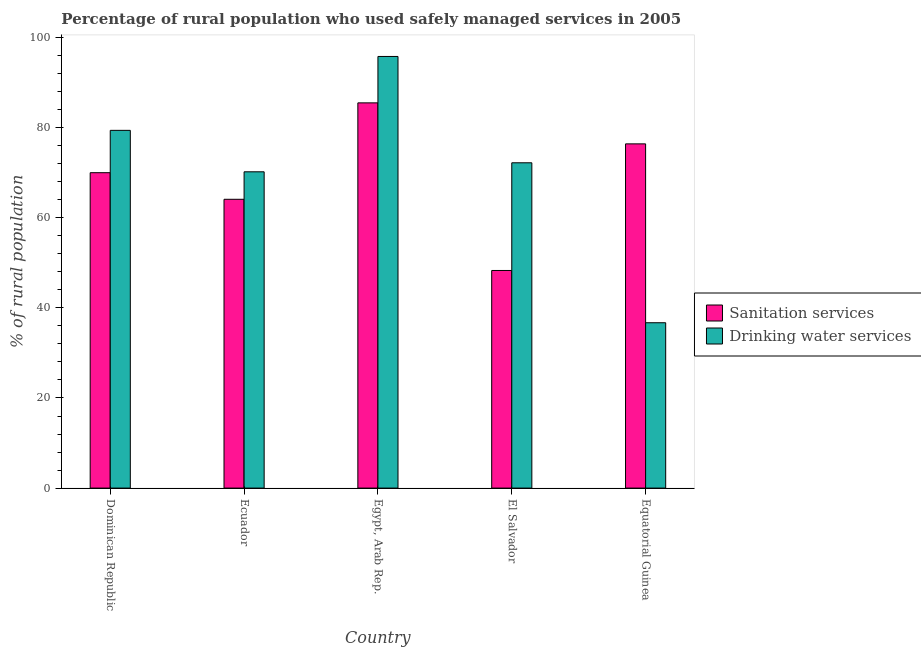How many bars are there on the 4th tick from the left?
Your response must be concise. 2. How many bars are there on the 2nd tick from the right?
Your answer should be compact. 2. What is the label of the 3rd group of bars from the left?
Your answer should be very brief. Egypt, Arab Rep. In how many cases, is the number of bars for a given country not equal to the number of legend labels?
Offer a very short reply. 0. What is the percentage of rural population who used sanitation services in Egypt, Arab Rep.?
Your response must be concise. 85.5. Across all countries, what is the maximum percentage of rural population who used drinking water services?
Provide a short and direct response. 95.8. Across all countries, what is the minimum percentage of rural population who used sanitation services?
Provide a succinct answer. 48.3. In which country was the percentage of rural population who used sanitation services maximum?
Give a very brief answer. Egypt, Arab Rep. In which country was the percentage of rural population who used sanitation services minimum?
Offer a very short reply. El Salvador. What is the total percentage of rural population who used sanitation services in the graph?
Your answer should be very brief. 344.3. What is the difference between the percentage of rural population who used drinking water services in Ecuador and that in Egypt, Arab Rep.?
Provide a short and direct response. -25.6. What is the difference between the percentage of rural population who used drinking water services in Ecuador and the percentage of rural population who used sanitation services in Egypt, Arab Rep.?
Your answer should be very brief. -15.3. What is the average percentage of rural population who used drinking water services per country?
Provide a short and direct response. 70.86. What is the difference between the percentage of rural population who used drinking water services and percentage of rural population who used sanitation services in Equatorial Guinea?
Provide a short and direct response. -39.7. In how many countries, is the percentage of rural population who used sanitation services greater than 80 %?
Give a very brief answer. 1. What is the ratio of the percentage of rural population who used drinking water services in Egypt, Arab Rep. to that in El Salvador?
Keep it short and to the point. 1.33. Is the percentage of rural population who used sanitation services in Dominican Republic less than that in El Salvador?
Give a very brief answer. No. What is the difference between the highest and the second highest percentage of rural population who used drinking water services?
Your response must be concise. 16.4. What is the difference between the highest and the lowest percentage of rural population who used sanitation services?
Your answer should be compact. 37.2. In how many countries, is the percentage of rural population who used drinking water services greater than the average percentage of rural population who used drinking water services taken over all countries?
Offer a terse response. 3. Is the sum of the percentage of rural population who used drinking water services in Dominican Republic and Ecuador greater than the maximum percentage of rural population who used sanitation services across all countries?
Your answer should be very brief. Yes. What does the 2nd bar from the left in Ecuador represents?
Your response must be concise. Drinking water services. What does the 1st bar from the right in Egypt, Arab Rep. represents?
Offer a very short reply. Drinking water services. Are all the bars in the graph horizontal?
Provide a short and direct response. No. How many countries are there in the graph?
Give a very brief answer. 5. What is the difference between two consecutive major ticks on the Y-axis?
Provide a succinct answer. 20. Are the values on the major ticks of Y-axis written in scientific E-notation?
Provide a short and direct response. No. Does the graph contain any zero values?
Provide a succinct answer. No. How many legend labels are there?
Offer a terse response. 2. What is the title of the graph?
Your answer should be compact. Percentage of rural population who used safely managed services in 2005. What is the label or title of the X-axis?
Your answer should be very brief. Country. What is the label or title of the Y-axis?
Offer a terse response. % of rural population. What is the % of rural population in Sanitation services in Dominican Republic?
Your answer should be compact. 70. What is the % of rural population of Drinking water services in Dominican Republic?
Offer a terse response. 79.4. What is the % of rural population of Sanitation services in Ecuador?
Your answer should be compact. 64.1. What is the % of rural population in Drinking water services in Ecuador?
Make the answer very short. 70.2. What is the % of rural population in Sanitation services in Egypt, Arab Rep.?
Ensure brevity in your answer.  85.5. What is the % of rural population of Drinking water services in Egypt, Arab Rep.?
Keep it short and to the point. 95.8. What is the % of rural population in Sanitation services in El Salvador?
Keep it short and to the point. 48.3. What is the % of rural population in Drinking water services in El Salvador?
Your response must be concise. 72.2. What is the % of rural population of Sanitation services in Equatorial Guinea?
Provide a short and direct response. 76.4. What is the % of rural population in Drinking water services in Equatorial Guinea?
Offer a terse response. 36.7. Across all countries, what is the maximum % of rural population of Sanitation services?
Give a very brief answer. 85.5. Across all countries, what is the maximum % of rural population in Drinking water services?
Offer a very short reply. 95.8. Across all countries, what is the minimum % of rural population of Sanitation services?
Give a very brief answer. 48.3. Across all countries, what is the minimum % of rural population in Drinking water services?
Make the answer very short. 36.7. What is the total % of rural population in Sanitation services in the graph?
Offer a terse response. 344.3. What is the total % of rural population in Drinking water services in the graph?
Your answer should be very brief. 354.3. What is the difference between the % of rural population of Drinking water services in Dominican Republic and that in Ecuador?
Keep it short and to the point. 9.2. What is the difference between the % of rural population of Sanitation services in Dominican Republic and that in Egypt, Arab Rep.?
Ensure brevity in your answer.  -15.5. What is the difference between the % of rural population of Drinking water services in Dominican Republic and that in Egypt, Arab Rep.?
Keep it short and to the point. -16.4. What is the difference between the % of rural population in Sanitation services in Dominican Republic and that in El Salvador?
Ensure brevity in your answer.  21.7. What is the difference between the % of rural population in Sanitation services in Dominican Republic and that in Equatorial Guinea?
Make the answer very short. -6.4. What is the difference between the % of rural population in Drinking water services in Dominican Republic and that in Equatorial Guinea?
Your response must be concise. 42.7. What is the difference between the % of rural population in Sanitation services in Ecuador and that in Egypt, Arab Rep.?
Provide a succinct answer. -21.4. What is the difference between the % of rural population of Drinking water services in Ecuador and that in Egypt, Arab Rep.?
Ensure brevity in your answer.  -25.6. What is the difference between the % of rural population of Drinking water services in Ecuador and that in El Salvador?
Your answer should be compact. -2. What is the difference between the % of rural population of Sanitation services in Ecuador and that in Equatorial Guinea?
Ensure brevity in your answer.  -12.3. What is the difference between the % of rural population of Drinking water services in Ecuador and that in Equatorial Guinea?
Ensure brevity in your answer.  33.5. What is the difference between the % of rural population of Sanitation services in Egypt, Arab Rep. and that in El Salvador?
Your answer should be very brief. 37.2. What is the difference between the % of rural population of Drinking water services in Egypt, Arab Rep. and that in El Salvador?
Your response must be concise. 23.6. What is the difference between the % of rural population in Sanitation services in Egypt, Arab Rep. and that in Equatorial Guinea?
Provide a short and direct response. 9.1. What is the difference between the % of rural population in Drinking water services in Egypt, Arab Rep. and that in Equatorial Guinea?
Give a very brief answer. 59.1. What is the difference between the % of rural population of Sanitation services in El Salvador and that in Equatorial Guinea?
Your answer should be very brief. -28.1. What is the difference between the % of rural population in Drinking water services in El Salvador and that in Equatorial Guinea?
Provide a succinct answer. 35.5. What is the difference between the % of rural population in Sanitation services in Dominican Republic and the % of rural population in Drinking water services in Egypt, Arab Rep.?
Keep it short and to the point. -25.8. What is the difference between the % of rural population in Sanitation services in Dominican Republic and the % of rural population in Drinking water services in El Salvador?
Your response must be concise. -2.2. What is the difference between the % of rural population of Sanitation services in Dominican Republic and the % of rural population of Drinking water services in Equatorial Guinea?
Provide a succinct answer. 33.3. What is the difference between the % of rural population of Sanitation services in Ecuador and the % of rural population of Drinking water services in Egypt, Arab Rep.?
Make the answer very short. -31.7. What is the difference between the % of rural population of Sanitation services in Ecuador and the % of rural population of Drinking water services in El Salvador?
Make the answer very short. -8.1. What is the difference between the % of rural population in Sanitation services in Ecuador and the % of rural population in Drinking water services in Equatorial Guinea?
Your answer should be compact. 27.4. What is the difference between the % of rural population in Sanitation services in Egypt, Arab Rep. and the % of rural population in Drinking water services in El Salvador?
Your response must be concise. 13.3. What is the difference between the % of rural population in Sanitation services in Egypt, Arab Rep. and the % of rural population in Drinking water services in Equatorial Guinea?
Give a very brief answer. 48.8. What is the average % of rural population in Sanitation services per country?
Your response must be concise. 68.86. What is the average % of rural population of Drinking water services per country?
Provide a short and direct response. 70.86. What is the difference between the % of rural population of Sanitation services and % of rural population of Drinking water services in Ecuador?
Make the answer very short. -6.1. What is the difference between the % of rural population in Sanitation services and % of rural population in Drinking water services in El Salvador?
Ensure brevity in your answer.  -23.9. What is the difference between the % of rural population in Sanitation services and % of rural population in Drinking water services in Equatorial Guinea?
Make the answer very short. 39.7. What is the ratio of the % of rural population of Sanitation services in Dominican Republic to that in Ecuador?
Your answer should be compact. 1.09. What is the ratio of the % of rural population of Drinking water services in Dominican Republic to that in Ecuador?
Provide a short and direct response. 1.13. What is the ratio of the % of rural population in Sanitation services in Dominican Republic to that in Egypt, Arab Rep.?
Offer a very short reply. 0.82. What is the ratio of the % of rural population of Drinking water services in Dominican Republic to that in Egypt, Arab Rep.?
Keep it short and to the point. 0.83. What is the ratio of the % of rural population in Sanitation services in Dominican Republic to that in El Salvador?
Offer a terse response. 1.45. What is the ratio of the % of rural population in Drinking water services in Dominican Republic to that in El Salvador?
Ensure brevity in your answer.  1.1. What is the ratio of the % of rural population in Sanitation services in Dominican Republic to that in Equatorial Guinea?
Offer a terse response. 0.92. What is the ratio of the % of rural population of Drinking water services in Dominican Republic to that in Equatorial Guinea?
Ensure brevity in your answer.  2.16. What is the ratio of the % of rural population in Sanitation services in Ecuador to that in Egypt, Arab Rep.?
Give a very brief answer. 0.75. What is the ratio of the % of rural population in Drinking water services in Ecuador to that in Egypt, Arab Rep.?
Offer a terse response. 0.73. What is the ratio of the % of rural population of Sanitation services in Ecuador to that in El Salvador?
Offer a very short reply. 1.33. What is the ratio of the % of rural population of Drinking water services in Ecuador to that in El Salvador?
Offer a terse response. 0.97. What is the ratio of the % of rural population in Sanitation services in Ecuador to that in Equatorial Guinea?
Offer a very short reply. 0.84. What is the ratio of the % of rural population in Drinking water services in Ecuador to that in Equatorial Guinea?
Offer a terse response. 1.91. What is the ratio of the % of rural population in Sanitation services in Egypt, Arab Rep. to that in El Salvador?
Your answer should be very brief. 1.77. What is the ratio of the % of rural population in Drinking water services in Egypt, Arab Rep. to that in El Salvador?
Offer a terse response. 1.33. What is the ratio of the % of rural population of Sanitation services in Egypt, Arab Rep. to that in Equatorial Guinea?
Your answer should be compact. 1.12. What is the ratio of the % of rural population of Drinking water services in Egypt, Arab Rep. to that in Equatorial Guinea?
Give a very brief answer. 2.61. What is the ratio of the % of rural population of Sanitation services in El Salvador to that in Equatorial Guinea?
Make the answer very short. 0.63. What is the ratio of the % of rural population of Drinking water services in El Salvador to that in Equatorial Guinea?
Provide a succinct answer. 1.97. What is the difference between the highest and the second highest % of rural population of Sanitation services?
Keep it short and to the point. 9.1. What is the difference between the highest and the lowest % of rural population of Sanitation services?
Provide a short and direct response. 37.2. What is the difference between the highest and the lowest % of rural population of Drinking water services?
Make the answer very short. 59.1. 